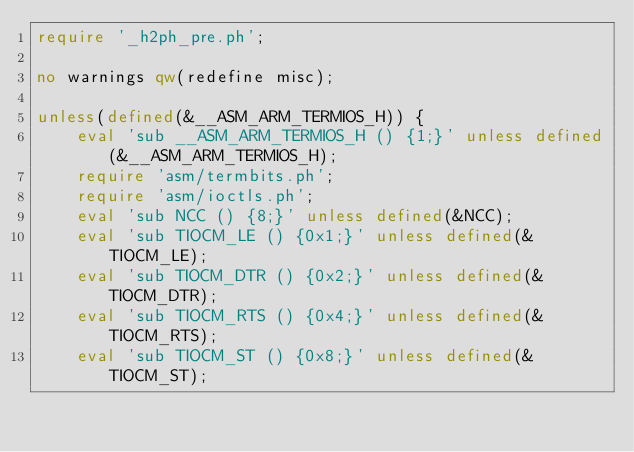<code> <loc_0><loc_0><loc_500><loc_500><_Perl_>require '_h2ph_pre.ph';

no warnings qw(redefine misc);

unless(defined(&__ASM_ARM_TERMIOS_H)) {
    eval 'sub __ASM_ARM_TERMIOS_H () {1;}' unless defined(&__ASM_ARM_TERMIOS_H);
    require 'asm/termbits.ph';
    require 'asm/ioctls.ph';
    eval 'sub NCC () {8;}' unless defined(&NCC);
    eval 'sub TIOCM_LE () {0x1;}' unless defined(&TIOCM_LE);
    eval 'sub TIOCM_DTR () {0x2;}' unless defined(&TIOCM_DTR);
    eval 'sub TIOCM_RTS () {0x4;}' unless defined(&TIOCM_RTS);
    eval 'sub TIOCM_ST () {0x8;}' unless defined(&TIOCM_ST);</code> 